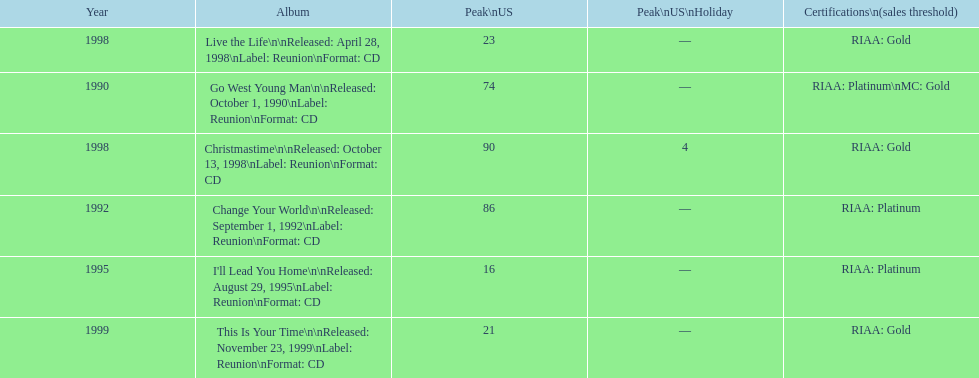How many songs are listed from 1998? 2. 